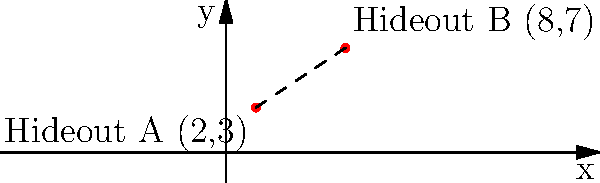Two of your hideout locations are plotted on a coordinate plane. Hideout A is at $(2,3)$ and Hideout B is at $(8,7)$. Calculate the straight-line distance between these two hideouts to determine the quickest escape route. To find the distance between two points on a coordinate plane, we use the distance formula:

$$d = \sqrt{(x_2 - x_1)^2 + (y_2 - y_1)^2}$$

Where $(x_1, y_1)$ is the coordinate of the first point and $(x_2, y_2)$ is the coordinate of the second point.

Step 1: Identify the coordinates
Hideout A: $(x_1, y_1) = (2, 3)$
Hideout B: $(x_2, y_2) = (8, 7)$

Step 2: Plug the values into the distance formula
$$d = \sqrt{(8 - 2)^2 + (7 - 3)^2}$$

Step 3: Simplify the expressions inside the parentheses
$$d = \sqrt{6^2 + 4^2}$$

Step 4: Calculate the squares
$$d = \sqrt{36 + 16}$$

Step 5: Add the values under the square root
$$d = \sqrt{52}$$

Step 6: Simplify the square root (optional)
$$d = 2\sqrt{13}$$

The distance between the two hideouts is $2\sqrt{13}$ units.
Answer: $2\sqrt{13}$ units 